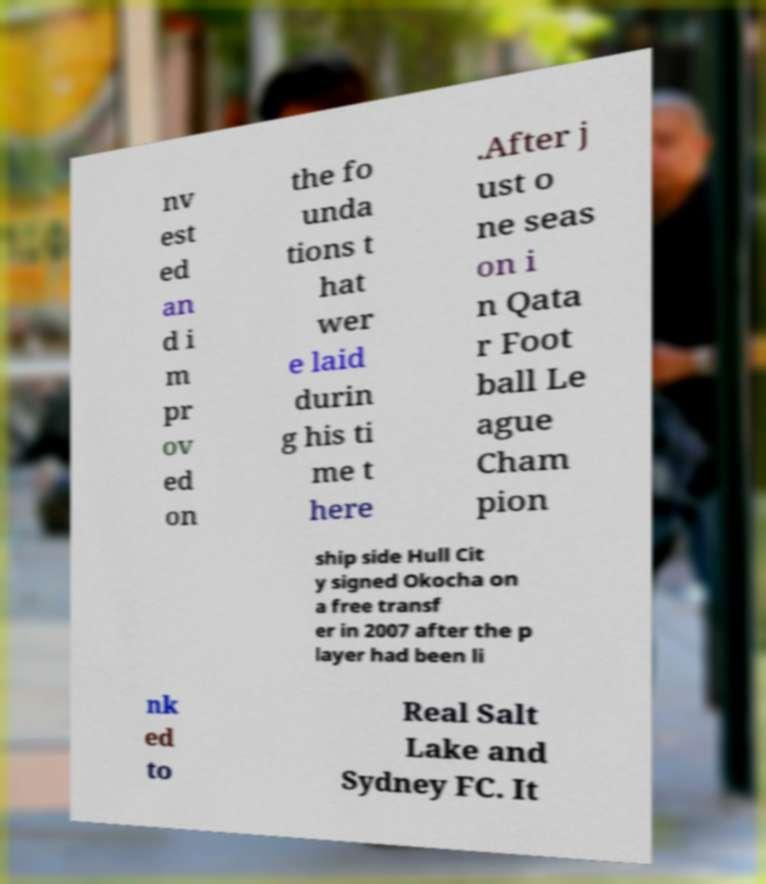Could you extract and type out the text from this image? nv est ed an d i m pr ov ed on the fo unda tions t hat wer e laid durin g his ti me t here .After j ust o ne seas on i n Qata r Foot ball Le ague Cham pion ship side Hull Cit y signed Okocha on a free transf er in 2007 after the p layer had been li nk ed to Real Salt Lake and Sydney FC. It 